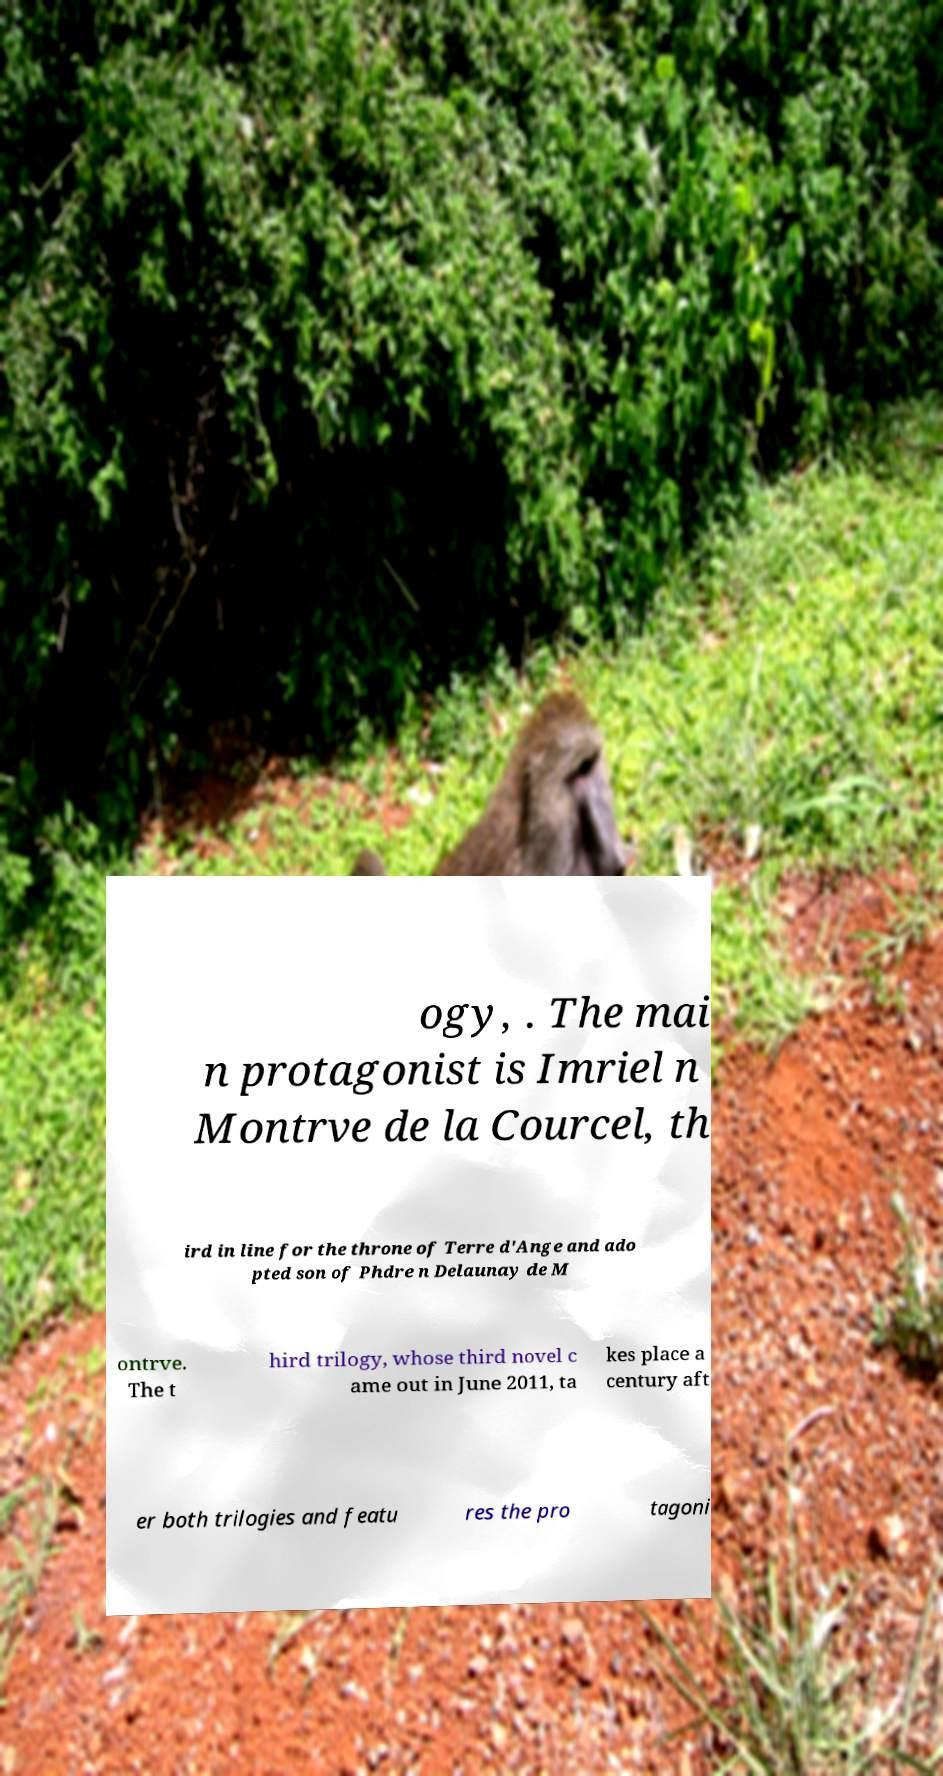Can you read and provide the text displayed in the image?This photo seems to have some interesting text. Can you extract and type it out for me? ogy, . The mai n protagonist is Imriel n Montrve de la Courcel, th ird in line for the throne of Terre d'Ange and ado pted son of Phdre n Delaunay de M ontrve. The t hird trilogy, whose third novel c ame out in June 2011, ta kes place a century aft er both trilogies and featu res the pro tagoni 